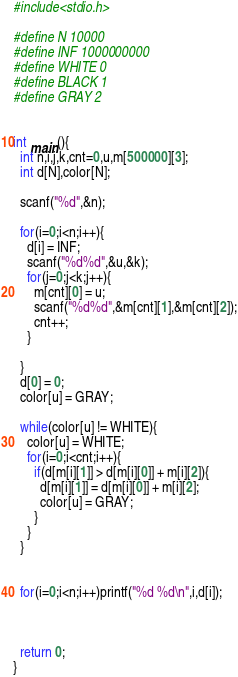<code> <loc_0><loc_0><loc_500><loc_500><_C_>#include<stdio.h>

#define N 10000
#define INF 1000000000
#define WHITE 0
#define BLACK 1
#define GRAY 2


int main(){
  int n,i,j,k,cnt=0,u,m[500000][3];
  int d[N],color[N];

  scanf("%d",&n);

  for(i=0;i<n;i++){
    d[i] = INF;
    scanf("%d%d",&u,&k);
    for(j=0;j<k;j++){
      m[cnt][0] = u;
      scanf("%d%d",&m[cnt][1],&m[cnt][2]);
      cnt++;
    }
    
  }
  d[0] = 0;
  color[u] = GRAY;

  while(color[u] != WHITE){
    color[u] = WHITE;
    for(i=0;i<cnt;i++){
      if(d[m[i][1]] > d[m[i][0]] + m[i][2]){
        d[m[i][1]] = d[m[i][0]] + m[i][2];
        color[u] = GRAY;
      }
    }
  }

  
  for(i=0;i<n;i++)printf("%d %d\n",i,d[i]);



  return 0;
}

</code> 